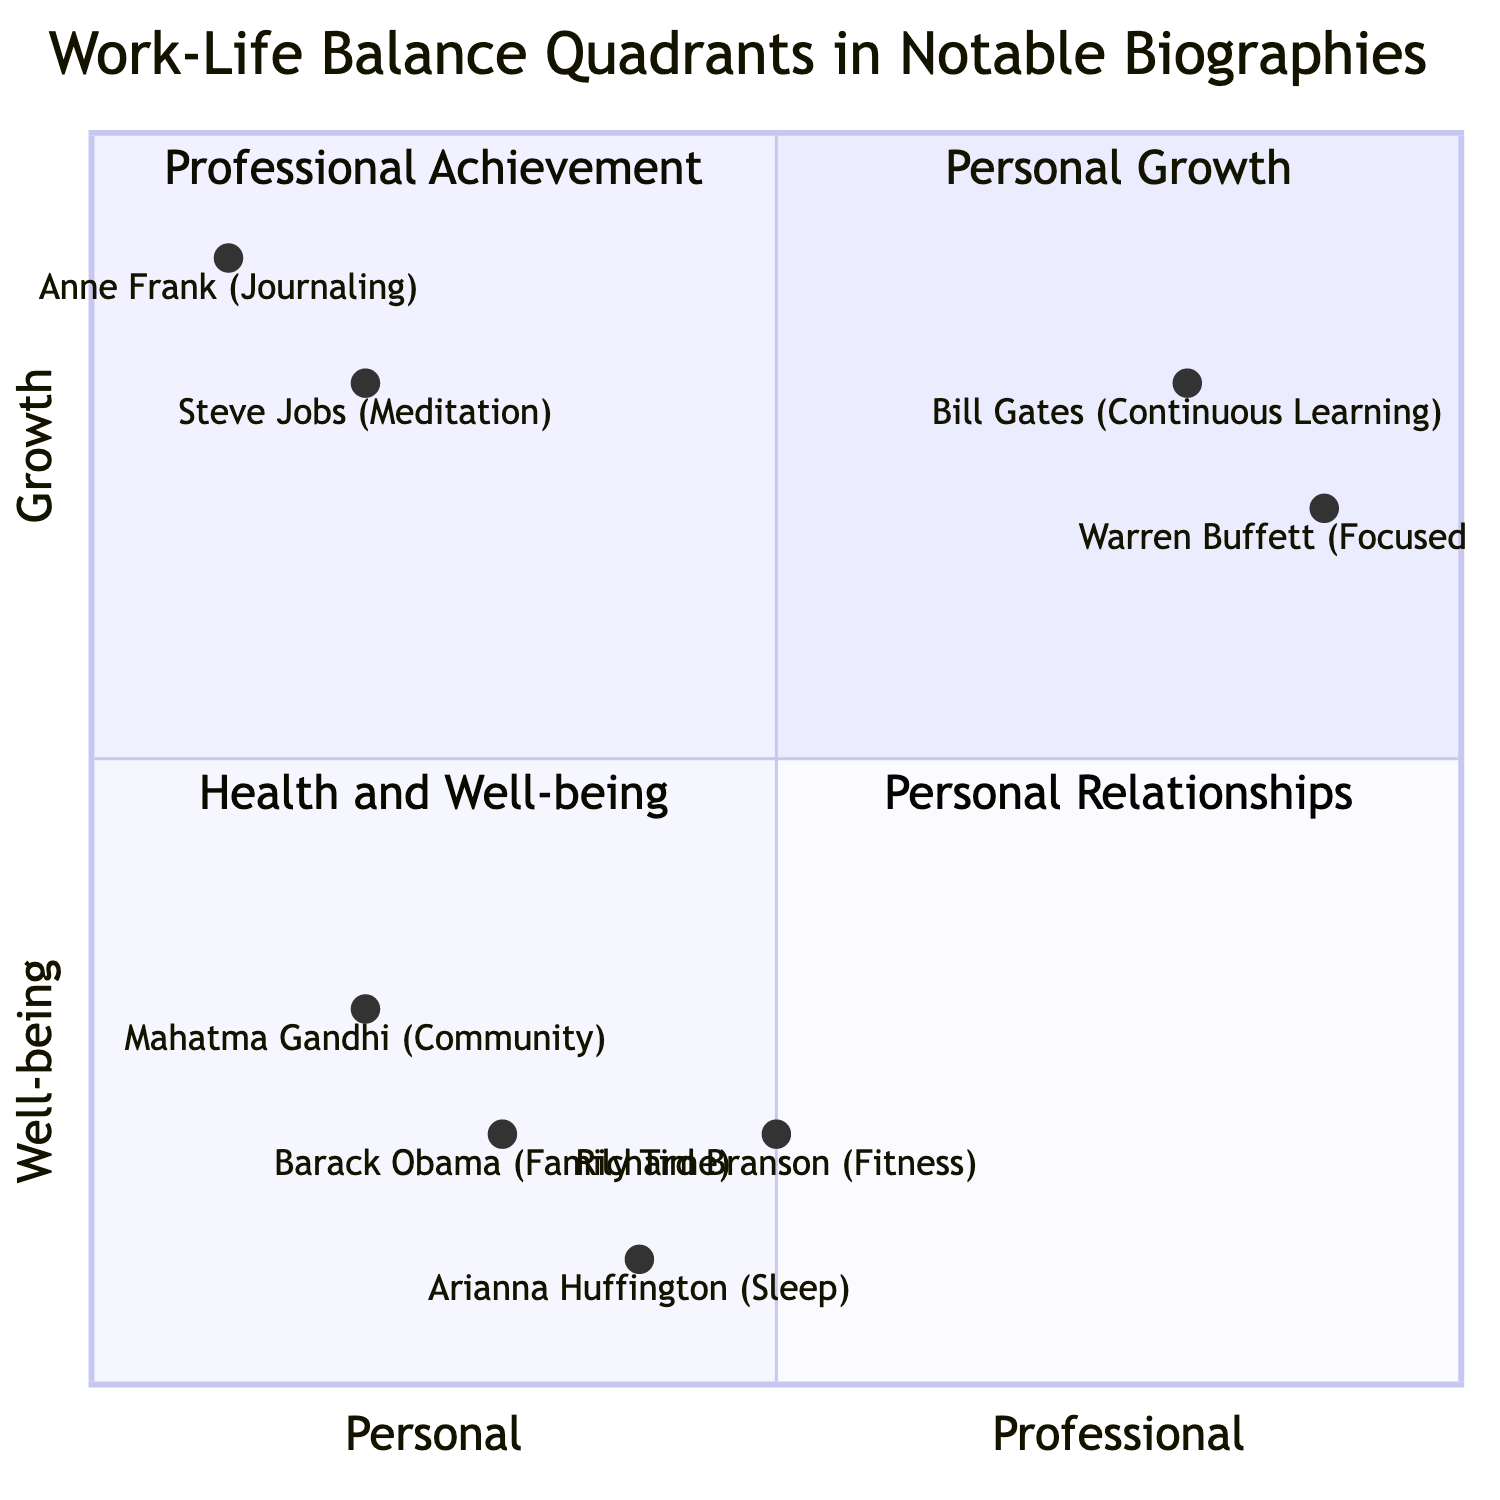What is the primary aspect of Steve Jobs in the diagram? The diagram shows Steve Jobs in the "Personal Growth" quadrant, with his aspect being "Meditation and Mindfulness."
Answer: Meditation and Mindfulness Which quadrant does Barack Obama belong to? Barack Obama is placed in the "Personal Relationships" quadrant, which focuses on maintaining family ties.
Answer: Personal Relationships How many notable individuals are represented in the "Health and Well-being" quadrant? There are two individuals in the "Health and Well-being" quadrant: Arianna Huffington and Richard Branson.
Answer: 2 Which individual is associated with "Continuous Learning"? Bill Gates is identified in the "Professional Achievement" quadrant, and his aspect is "Continuous Learning."
Answer: Bill Gates What is the relationship between personal well-being and professional achievement in this diagram? In the quadrant chart, aspects of personal well-being, such as health and family time, contrast with aspects of professional achievement, suggesting that work-life balance involves managing both sides effectively.
Answer: They contrast Which element represents community engagement? Mahatma Gandhi is the element that represents "Community Engagement," situated in the "Personal Relationships" quadrant.
Answer: Mahatma Gandhi How does the aspect of "Focused Work" contribute to professional achievement? The diagram indicates that Warren Buffett, through "Focused Work Hours," optimizes productivity, which enhances his professional achievements.
Answer: Optimizes Productivity In which quadrant would you find individuals focused on personal growth? The "Personal Growth" quadrant contains individuals like Steve Jobs and Anne Frank, emphasizing self-development aspects.
Answer: Personal Growth 